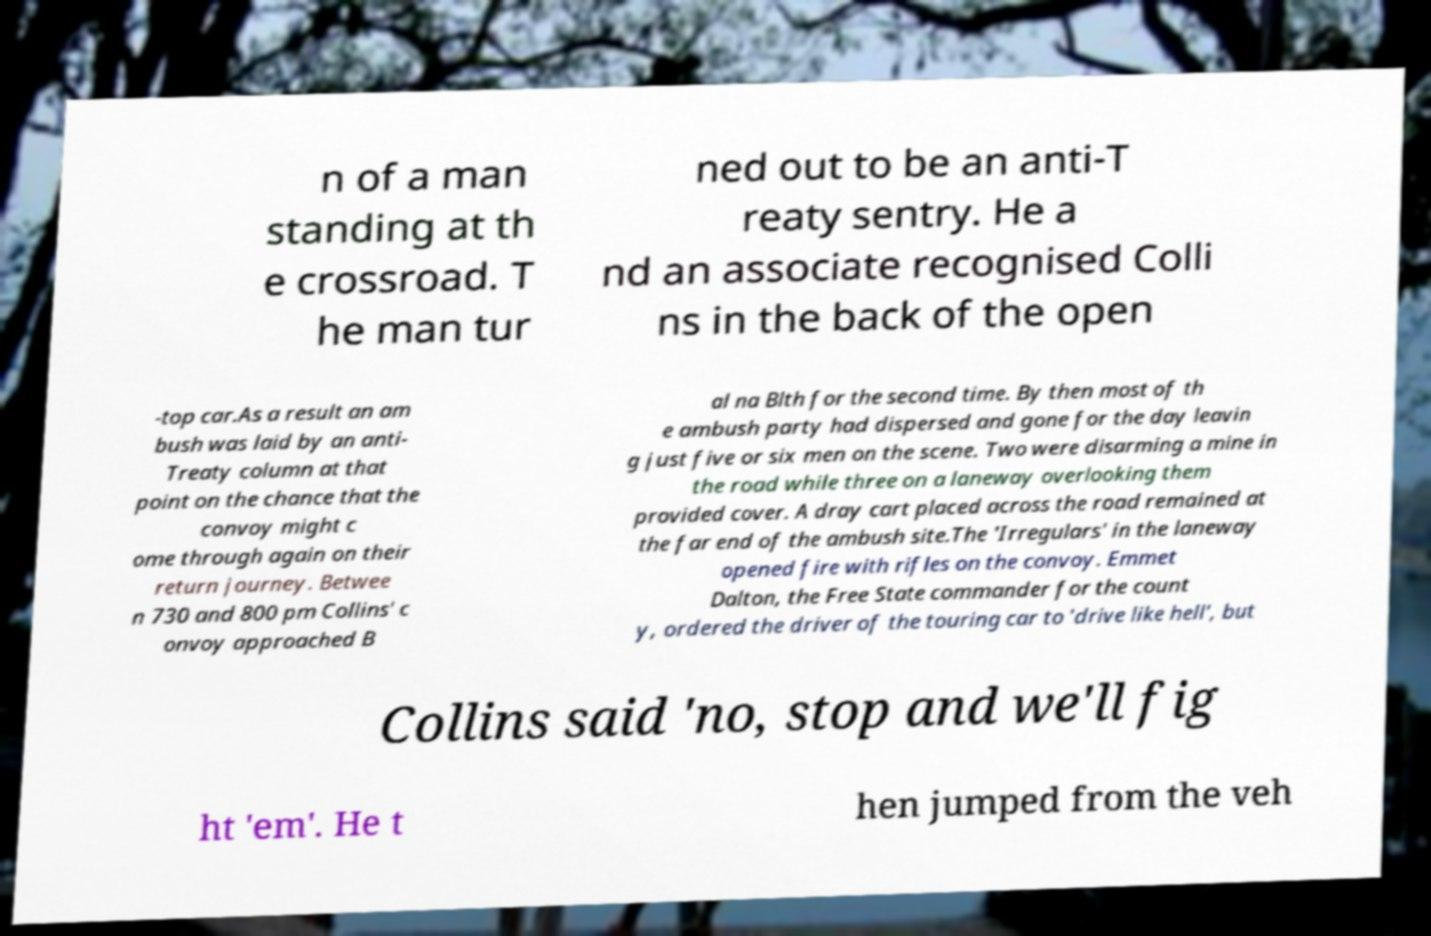Could you extract and type out the text from this image? n of a man standing at th e crossroad. T he man tur ned out to be an anti-T reaty sentry. He a nd an associate recognised Colli ns in the back of the open -top car.As a result an am bush was laid by an anti- Treaty column at that point on the chance that the convoy might c ome through again on their return journey. Betwee n 730 and 800 pm Collins' c onvoy approached B al na Blth for the second time. By then most of th e ambush party had dispersed and gone for the day leavin g just five or six men on the scene. Two were disarming a mine in the road while three on a laneway overlooking them provided cover. A dray cart placed across the road remained at the far end of the ambush site.The 'Irregulars' in the laneway opened fire with rifles on the convoy. Emmet Dalton, the Free State commander for the count y, ordered the driver of the touring car to 'drive like hell', but Collins said 'no, stop and we'll fig ht 'em'. He t hen jumped from the veh 